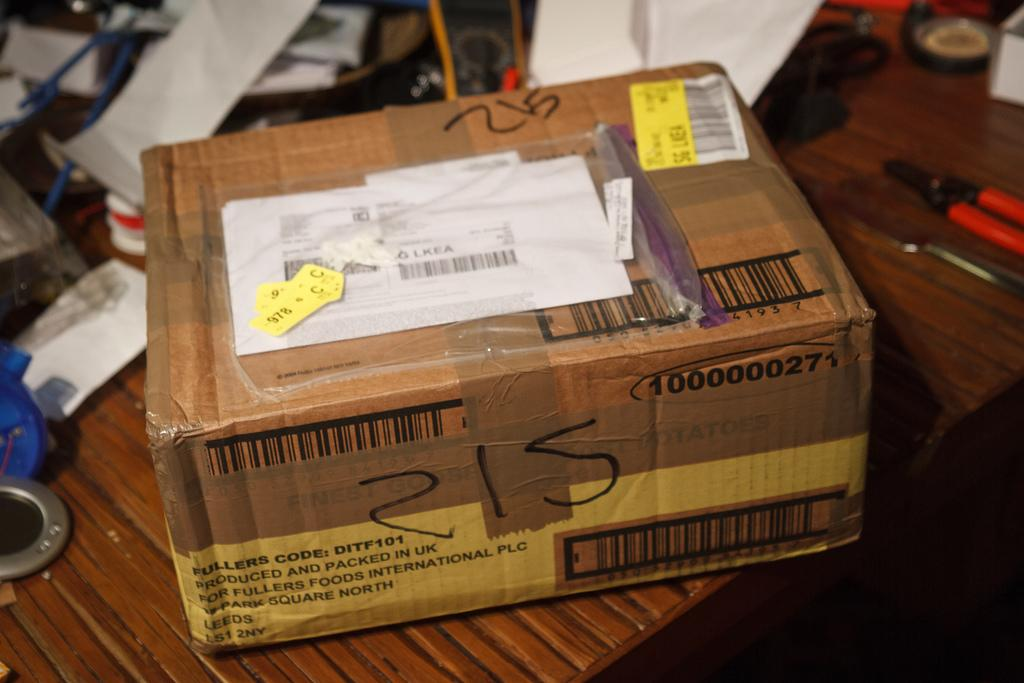<image>
Create a compact narrative representing the image presented. A package from UK is on the table with some other tools. 